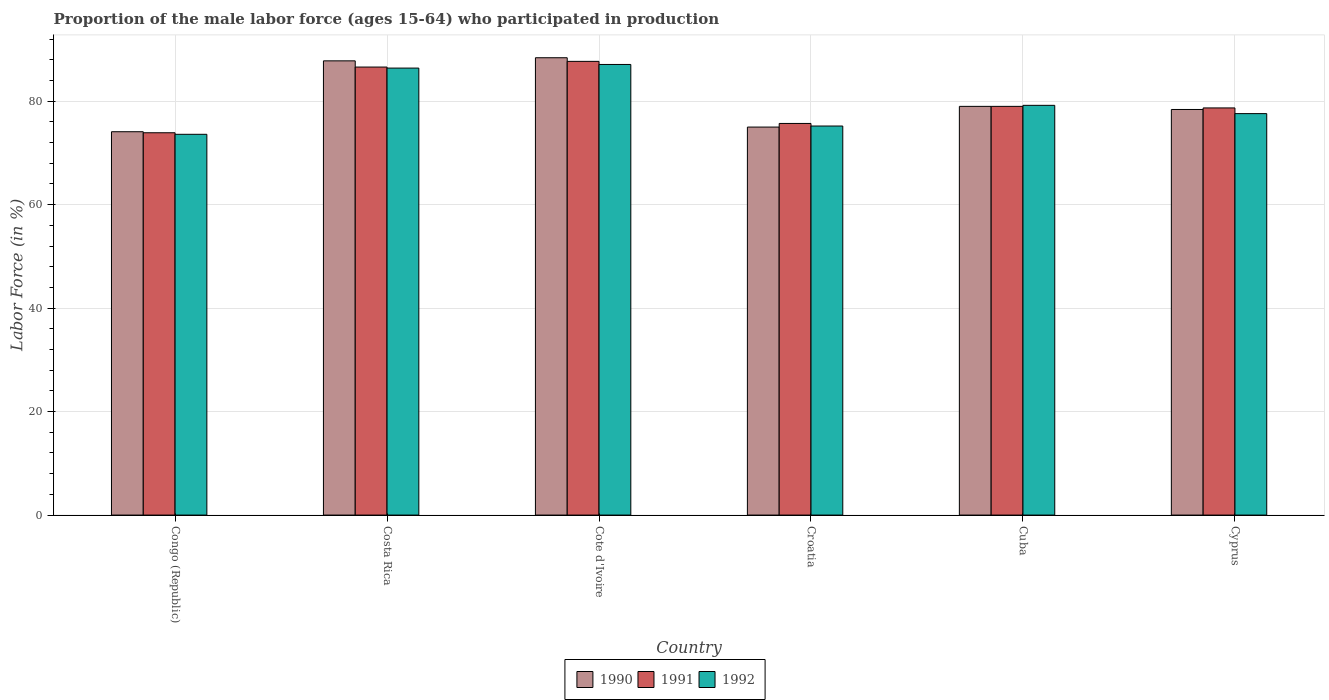Are the number of bars on each tick of the X-axis equal?
Your answer should be compact. Yes. How many bars are there on the 1st tick from the left?
Your answer should be very brief. 3. How many bars are there on the 5th tick from the right?
Keep it short and to the point. 3. What is the label of the 6th group of bars from the left?
Make the answer very short. Cyprus. In how many cases, is the number of bars for a given country not equal to the number of legend labels?
Ensure brevity in your answer.  0. What is the proportion of the male labor force who participated in production in 1990 in Cote d'Ivoire?
Provide a short and direct response. 88.4. Across all countries, what is the maximum proportion of the male labor force who participated in production in 1991?
Offer a very short reply. 87.7. Across all countries, what is the minimum proportion of the male labor force who participated in production in 1991?
Your response must be concise. 73.9. In which country was the proportion of the male labor force who participated in production in 1990 maximum?
Keep it short and to the point. Cote d'Ivoire. In which country was the proportion of the male labor force who participated in production in 1992 minimum?
Your answer should be very brief. Congo (Republic). What is the total proportion of the male labor force who participated in production in 1991 in the graph?
Provide a short and direct response. 481.6. What is the difference between the proportion of the male labor force who participated in production in 1992 in Congo (Republic) and that in Costa Rica?
Provide a succinct answer. -12.8. What is the difference between the proportion of the male labor force who participated in production in 1990 in Congo (Republic) and the proportion of the male labor force who participated in production in 1992 in Cyprus?
Offer a terse response. -3.5. What is the average proportion of the male labor force who participated in production in 1991 per country?
Provide a short and direct response. 80.27. What is the difference between the proportion of the male labor force who participated in production of/in 1991 and proportion of the male labor force who participated in production of/in 1990 in Costa Rica?
Offer a very short reply. -1.2. In how many countries, is the proportion of the male labor force who participated in production in 1991 greater than 36 %?
Offer a terse response. 6. What is the ratio of the proportion of the male labor force who participated in production in 1991 in Congo (Republic) to that in Cyprus?
Make the answer very short. 0.94. Is the difference between the proportion of the male labor force who participated in production in 1991 in Congo (Republic) and Cyprus greater than the difference between the proportion of the male labor force who participated in production in 1990 in Congo (Republic) and Cyprus?
Your response must be concise. No. What is the difference between the highest and the second highest proportion of the male labor force who participated in production in 1990?
Ensure brevity in your answer.  9.4. What is the difference between the highest and the lowest proportion of the male labor force who participated in production in 1990?
Ensure brevity in your answer.  14.3. Is the sum of the proportion of the male labor force who participated in production in 1992 in Cote d'Ivoire and Cuba greater than the maximum proportion of the male labor force who participated in production in 1991 across all countries?
Your answer should be compact. Yes. What does the 3rd bar from the left in Cyprus represents?
Provide a short and direct response. 1992. What does the 3rd bar from the right in Cote d'Ivoire represents?
Offer a very short reply. 1990. Is it the case that in every country, the sum of the proportion of the male labor force who participated in production in 1990 and proportion of the male labor force who participated in production in 1992 is greater than the proportion of the male labor force who participated in production in 1991?
Offer a very short reply. Yes. Are all the bars in the graph horizontal?
Provide a short and direct response. No. What is the difference between two consecutive major ticks on the Y-axis?
Offer a very short reply. 20. Are the values on the major ticks of Y-axis written in scientific E-notation?
Your answer should be very brief. No. Does the graph contain grids?
Provide a succinct answer. Yes. What is the title of the graph?
Provide a succinct answer. Proportion of the male labor force (ages 15-64) who participated in production. What is the label or title of the Y-axis?
Your answer should be compact. Labor Force (in %). What is the Labor Force (in %) of 1990 in Congo (Republic)?
Keep it short and to the point. 74.1. What is the Labor Force (in %) of 1991 in Congo (Republic)?
Your answer should be very brief. 73.9. What is the Labor Force (in %) in 1992 in Congo (Republic)?
Your answer should be very brief. 73.6. What is the Labor Force (in %) of 1990 in Costa Rica?
Give a very brief answer. 87.8. What is the Labor Force (in %) in 1991 in Costa Rica?
Make the answer very short. 86.6. What is the Labor Force (in %) of 1992 in Costa Rica?
Ensure brevity in your answer.  86.4. What is the Labor Force (in %) in 1990 in Cote d'Ivoire?
Offer a very short reply. 88.4. What is the Labor Force (in %) of 1991 in Cote d'Ivoire?
Your response must be concise. 87.7. What is the Labor Force (in %) in 1992 in Cote d'Ivoire?
Give a very brief answer. 87.1. What is the Labor Force (in %) of 1991 in Croatia?
Your answer should be very brief. 75.7. What is the Labor Force (in %) of 1992 in Croatia?
Your response must be concise. 75.2. What is the Labor Force (in %) of 1990 in Cuba?
Offer a terse response. 79. What is the Labor Force (in %) in 1991 in Cuba?
Make the answer very short. 79. What is the Labor Force (in %) in 1992 in Cuba?
Your answer should be compact. 79.2. What is the Labor Force (in %) in 1990 in Cyprus?
Your response must be concise. 78.4. What is the Labor Force (in %) in 1991 in Cyprus?
Offer a very short reply. 78.7. What is the Labor Force (in %) of 1992 in Cyprus?
Keep it short and to the point. 77.6. Across all countries, what is the maximum Labor Force (in %) in 1990?
Offer a terse response. 88.4. Across all countries, what is the maximum Labor Force (in %) of 1991?
Your answer should be compact. 87.7. Across all countries, what is the maximum Labor Force (in %) of 1992?
Provide a short and direct response. 87.1. Across all countries, what is the minimum Labor Force (in %) in 1990?
Your answer should be very brief. 74.1. Across all countries, what is the minimum Labor Force (in %) in 1991?
Offer a very short reply. 73.9. Across all countries, what is the minimum Labor Force (in %) in 1992?
Your answer should be compact. 73.6. What is the total Labor Force (in %) of 1990 in the graph?
Provide a succinct answer. 482.7. What is the total Labor Force (in %) of 1991 in the graph?
Your answer should be compact. 481.6. What is the total Labor Force (in %) in 1992 in the graph?
Keep it short and to the point. 479.1. What is the difference between the Labor Force (in %) of 1990 in Congo (Republic) and that in Costa Rica?
Provide a succinct answer. -13.7. What is the difference between the Labor Force (in %) in 1990 in Congo (Republic) and that in Cote d'Ivoire?
Provide a short and direct response. -14.3. What is the difference between the Labor Force (in %) in 1991 in Congo (Republic) and that in Cote d'Ivoire?
Your answer should be compact. -13.8. What is the difference between the Labor Force (in %) of 1990 in Congo (Republic) and that in Croatia?
Offer a terse response. -0.9. What is the difference between the Labor Force (in %) in 1991 in Congo (Republic) and that in Croatia?
Offer a terse response. -1.8. What is the difference between the Labor Force (in %) of 1991 in Congo (Republic) and that in Cuba?
Provide a short and direct response. -5.1. What is the difference between the Labor Force (in %) of 1990 in Congo (Republic) and that in Cyprus?
Your answer should be very brief. -4.3. What is the difference between the Labor Force (in %) in 1992 in Costa Rica and that in Cote d'Ivoire?
Provide a succinct answer. -0.7. What is the difference between the Labor Force (in %) in 1990 in Costa Rica and that in Croatia?
Your response must be concise. 12.8. What is the difference between the Labor Force (in %) of 1991 in Costa Rica and that in Croatia?
Your response must be concise. 10.9. What is the difference between the Labor Force (in %) of 1990 in Costa Rica and that in Cuba?
Your answer should be compact. 8.8. What is the difference between the Labor Force (in %) of 1991 in Costa Rica and that in Cuba?
Keep it short and to the point. 7.6. What is the difference between the Labor Force (in %) of 1990 in Costa Rica and that in Cyprus?
Keep it short and to the point. 9.4. What is the difference between the Labor Force (in %) in 1991 in Costa Rica and that in Cyprus?
Your answer should be very brief. 7.9. What is the difference between the Labor Force (in %) of 1992 in Costa Rica and that in Cyprus?
Ensure brevity in your answer.  8.8. What is the difference between the Labor Force (in %) in 1991 in Cote d'Ivoire and that in Croatia?
Your answer should be very brief. 12. What is the difference between the Labor Force (in %) of 1990 in Cote d'Ivoire and that in Cuba?
Offer a terse response. 9.4. What is the difference between the Labor Force (in %) of 1991 in Cote d'Ivoire and that in Cuba?
Ensure brevity in your answer.  8.7. What is the difference between the Labor Force (in %) in 1992 in Cote d'Ivoire and that in Cuba?
Keep it short and to the point. 7.9. What is the difference between the Labor Force (in %) of 1990 in Cote d'Ivoire and that in Cyprus?
Offer a very short reply. 10. What is the difference between the Labor Force (in %) of 1991 in Cote d'Ivoire and that in Cyprus?
Your response must be concise. 9. What is the difference between the Labor Force (in %) in 1991 in Croatia and that in Cuba?
Your answer should be compact. -3.3. What is the difference between the Labor Force (in %) of 1990 in Croatia and that in Cyprus?
Give a very brief answer. -3.4. What is the difference between the Labor Force (in %) of 1991 in Croatia and that in Cyprus?
Your answer should be very brief. -3. What is the difference between the Labor Force (in %) of 1991 in Cuba and that in Cyprus?
Offer a terse response. 0.3. What is the difference between the Labor Force (in %) of 1992 in Cuba and that in Cyprus?
Keep it short and to the point. 1.6. What is the difference between the Labor Force (in %) of 1990 in Congo (Republic) and the Labor Force (in %) of 1991 in Costa Rica?
Your answer should be very brief. -12.5. What is the difference between the Labor Force (in %) of 1990 in Congo (Republic) and the Labor Force (in %) of 1992 in Costa Rica?
Provide a short and direct response. -12.3. What is the difference between the Labor Force (in %) of 1991 in Congo (Republic) and the Labor Force (in %) of 1992 in Cote d'Ivoire?
Your answer should be compact. -13.2. What is the difference between the Labor Force (in %) of 1990 in Congo (Republic) and the Labor Force (in %) of 1991 in Croatia?
Ensure brevity in your answer.  -1.6. What is the difference between the Labor Force (in %) of 1990 in Congo (Republic) and the Labor Force (in %) of 1992 in Croatia?
Provide a succinct answer. -1.1. What is the difference between the Labor Force (in %) of 1990 in Congo (Republic) and the Labor Force (in %) of 1991 in Cuba?
Make the answer very short. -4.9. What is the difference between the Labor Force (in %) in 1990 in Congo (Republic) and the Labor Force (in %) in 1992 in Cuba?
Provide a short and direct response. -5.1. What is the difference between the Labor Force (in %) in 1991 in Congo (Republic) and the Labor Force (in %) in 1992 in Cuba?
Your answer should be compact. -5.3. What is the difference between the Labor Force (in %) in 1990 in Congo (Republic) and the Labor Force (in %) in 1991 in Cyprus?
Your response must be concise. -4.6. What is the difference between the Labor Force (in %) in 1991 in Congo (Republic) and the Labor Force (in %) in 1992 in Cyprus?
Provide a short and direct response. -3.7. What is the difference between the Labor Force (in %) in 1990 in Costa Rica and the Labor Force (in %) in 1991 in Cote d'Ivoire?
Give a very brief answer. 0.1. What is the difference between the Labor Force (in %) in 1990 in Costa Rica and the Labor Force (in %) in 1991 in Croatia?
Your answer should be very brief. 12.1. What is the difference between the Labor Force (in %) of 1991 in Costa Rica and the Labor Force (in %) of 1992 in Croatia?
Give a very brief answer. 11.4. What is the difference between the Labor Force (in %) in 1990 in Costa Rica and the Labor Force (in %) in 1992 in Cyprus?
Give a very brief answer. 10.2. What is the difference between the Labor Force (in %) of 1990 in Cote d'Ivoire and the Labor Force (in %) of 1992 in Croatia?
Ensure brevity in your answer.  13.2. What is the difference between the Labor Force (in %) of 1990 in Cote d'Ivoire and the Labor Force (in %) of 1992 in Cuba?
Make the answer very short. 9.2. What is the difference between the Labor Force (in %) of 1991 in Cote d'Ivoire and the Labor Force (in %) of 1992 in Cyprus?
Your answer should be compact. 10.1. What is the difference between the Labor Force (in %) of 1990 in Croatia and the Labor Force (in %) of 1991 in Cuba?
Give a very brief answer. -4. What is the difference between the Labor Force (in %) of 1991 in Croatia and the Labor Force (in %) of 1992 in Cuba?
Your answer should be compact. -3.5. What is the difference between the Labor Force (in %) in 1990 in Cuba and the Labor Force (in %) in 1991 in Cyprus?
Provide a short and direct response. 0.3. What is the difference between the Labor Force (in %) of 1991 in Cuba and the Labor Force (in %) of 1992 in Cyprus?
Your answer should be compact. 1.4. What is the average Labor Force (in %) of 1990 per country?
Provide a short and direct response. 80.45. What is the average Labor Force (in %) in 1991 per country?
Your answer should be compact. 80.27. What is the average Labor Force (in %) of 1992 per country?
Provide a succinct answer. 79.85. What is the difference between the Labor Force (in %) in 1990 and Labor Force (in %) in 1992 in Congo (Republic)?
Offer a very short reply. 0.5. What is the difference between the Labor Force (in %) of 1990 and Labor Force (in %) of 1992 in Costa Rica?
Offer a very short reply. 1.4. What is the difference between the Labor Force (in %) in 1990 and Labor Force (in %) in 1991 in Cote d'Ivoire?
Your response must be concise. 0.7. What is the difference between the Labor Force (in %) of 1990 and Labor Force (in %) of 1992 in Cote d'Ivoire?
Offer a very short reply. 1.3. What is the difference between the Labor Force (in %) in 1991 and Labor Force (in %) in 1992 in Croatia?
Keep it short and to the point. 0.5. What is the difference between the Labor Force (in %) of 1990 and Labor Force (in %) of 1991 in Cuba?
Offer a terse response. 0. What is the difference between the Labor Force (in %) in 1990 and Labor Force (in %) in 1991 in Cyprus?
Your answer should be very brief. -0.3. What is the ratio of the Labor Force (in %) of 1990 in Congo (Republic) to that in Costa Rica?
Your response must be concise. 0.84. What is the ratio of the Labor Force (in %) of 1991 in Congo (Republic) to that in Costa Rica?
Keep it short and to the point. 0.85. What is the ratio of the Labor Force (in %) in 1992 in Congo (Republic) to that in Costa Rica?
Your answer should be very brief. 0.85. What is the ratio of the Labor Force (in %) in 1990 in Congo (Republic) to that in Cote d'Ivoire?
Your response must be concise. 0.84. What is the ratio of the Labor Force (in %) of 1991 in Congo (Republic) to that in Cote d'Ivoire?
Provide a succinct answer. 0.84. What is the ratio of the Labor Force (in %) of 1992 in Congo (Republic) to that in Cote d'Ivoire?
Provide a short and direct response. 0.84. What is the ratio of the Labor Force (in %) of 1990 in Congo (Republic) to that in Croatia?
Offer a very short reply. 0.99. What is the ratio of the Labor Force (in %) in 1991 in Congo (Republic) to that in Croatia?
Give a very brief answer. 0.98. What is the ratio of the Labor Force (in %) of 1992 in Congo (Republic) to that in Croatia?
Your answer should be compact. 0.98. What is the ratio of the Labor Force (in %) in 1990 in Congo (Republic) to that in Cuba?
Make the answer very short. 0.94. What is the ratio of the Labor Force (in %) in 1991 in Congo (Republic) to that in Cuba?
Offer a terse response. 0.94. What is the ratio of the Labor Force (in %) in 1992 in Congo (Republic) to that in Cuba?
Offer a terse response. 0.93. What is the ratio of the Labor Force (in %) of 1990 in Congo (Republic) to that in Cyprus?
Your response must be concise. 0.95. What is the ratio of the Labor Force (in %) of 1991 in Congo (Republic) to that in Cyprus?
Provide a succinct answer. 0.94. What is the ratio of the Labor Force (in %) in 1992 in Congo (Republic) to that in Cyprus?
Your response must be concise. 0.95. What is the ratio of the Labor Force (in %) of 1990 in Costa Rica to that in Cote d'Ivoire?
Make the answer very short. 0.99. What is the ratio of the Labor Force (in %) in 1991 in Costa Rica to that in Cote d'Ivoire?
Your answer should be very brief. 0.99. What is the ratio of the Labor Force (in %) of 1990 in Costa Rica to that in Croatia?
Your answer should be compact. 1.17. What is the ratio of the Labor Force (in %) of 1991 in Costa Rica to that in Croatia?
Your answer should be compact. 1.14. What is the ratio of the Labor Force (in %) of 1992 in Costa Rica to that in Croatia?
Offer a very short reply. 1.15. What is the ratio of the Labor Force (in %) in 1990 in Costa Rica to that in Cuba?
Keep it short and to the point. 1.11. What is the ratio of the Labor Force (in %) in 1991 in Costa Rica to that in Cuba?
Your answer should be compact. 1.1. What is the ratio of the Labor Force (in %) in 1990 in Costa Rica to that in Cyprus?
Provide a short and direct response. 1.12. What is the ratio of the Labor Force (in %) of 1991 in Costa Rica to that in Cyprus?
Provide a short and direct response. 1.1. What is the ratio of the Labor Force (in %) in 1992 in Costa Rica to that in Cyprus?
Make the answer very short. 1.11. What is the ratio of the Labor Force (in %) of 1990 in Cote d'Ivoire to that in Croatia?
Ensure brevity in your answer.  1.18. What is the ratio of the Labor Force (in %) of 1991 in Cote d'Ivoire to that in Croatia?
Provide a short and direct response. 1.16. What is the ratio of the Labor Force (in %) of 1992 in Cote d'Ivoire to that in Croatia?
Offer a terse response. 1.16. What is the ratio of the Labor Force (in %) of 1990 in Cote d'Ivoire to that in Cuba?
Offer a terse response. 1.12. What is the ratio of the Labor Force (in %) of 1991 in Cote d'Ivoire to that in Cuba?
Offer a terse response. 1.11. What is the ratio of the Labor Force (in %) of 1992 in Cote d'Ivoire to that in Cuba?
Your answer should be compact. 1.1. What is the ratio of the Labor Force (in %) of 1990 in Cote d'Ivoire to that in Cyprus?
Provide a succinct answer. 1.13. What is the ratio of the Labor Force (in %) of 1991 in Cote d'Ivoire to that in Cyprus?
Provide a short and direct response. 1.11. What is the ratio of the Labor Force (in %) in 1992 in Cote d'Ivoire to that in Cyprus?
Offer a terse response. 1.12. What is the ratio of the Labor Force (in %) of 1990 in Croatia to that in Cuba?
Ensure brevity in your answer.  0.95. What is the ratio of the Labor Force (in %) in 1991 in Croatia to that in Cuba?
Your response must be concise. 0.96. What is the ratio of the Labor Force (in %) of 1992 in Croatia to that in Cuba?
Your answer should be very brief. 0.95. What is the ratio of the Labor Force (in %) in 1990 in Croatia to that in Cyprus?
Your answer should be compact. 0.96. What is the ratio of the Labor Force (in %) of 1991 in Croatia to that in Cyprus?
Make the answer very short. 0.96. What is the ratio of the Labor Force (in %) of 1992 in Croatia to that in Cyprus?
Give a very brief answer. 0.97. What is the ratio of the Labor Force (in %) in 1990 in Cuba to that in Cyprus?
Ensure brevity in your answer.  1.01. What is the ratio of the Labor Force (in %) of 1992 in Cuba to that in Cyprus?
Provide a succinct answer. 1.02. What is the difference between the highest and the second highest Labor Force (in %) of 1990?
Offer a very short reply. 0.6. What is the difference between the highest and the second highest Labor Force (in %) of 1992?
Your answer should be compact. 0.7. What is the difference between the highest and the lowest Labor Force (in %) of 1990?
Make the answer very short. 14.3. What is the difference between the highest and the lowest Labor Force (in %) in 1991?
Offer a very short reply. 13.8. What is the difference between the highest and the lowest Labor Force (in %) in 1992?
Your answer should be very brief. 13.5. 